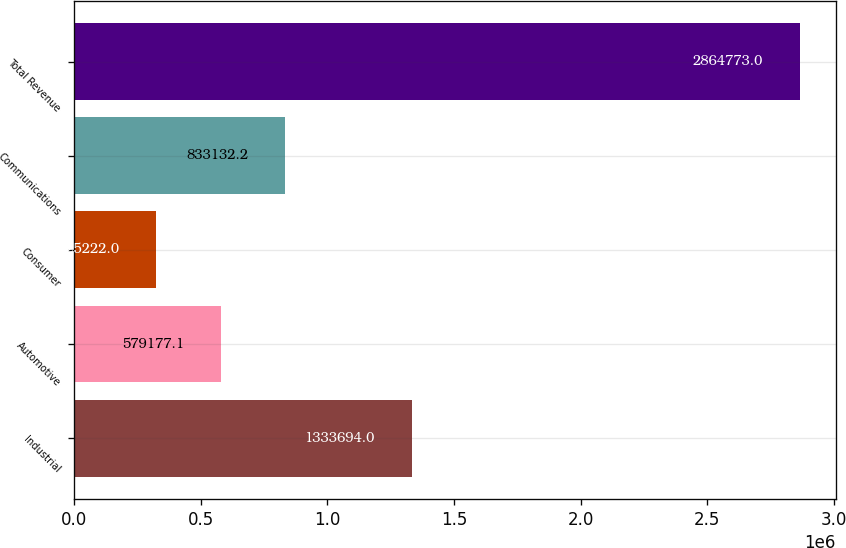Convert chart. <chart><loc_0><loc_0><loc_500><loc_500><bar_chart><fcel>Industrial<fcel>Automotive<fcel>Consumer<fcel>Communications<fcel>Total Revenue<nl><fcel>1.33369e+06<fcel>579177<fcel>325222<fcel>833132<fcel>2.86477e+06<nl></chart> 